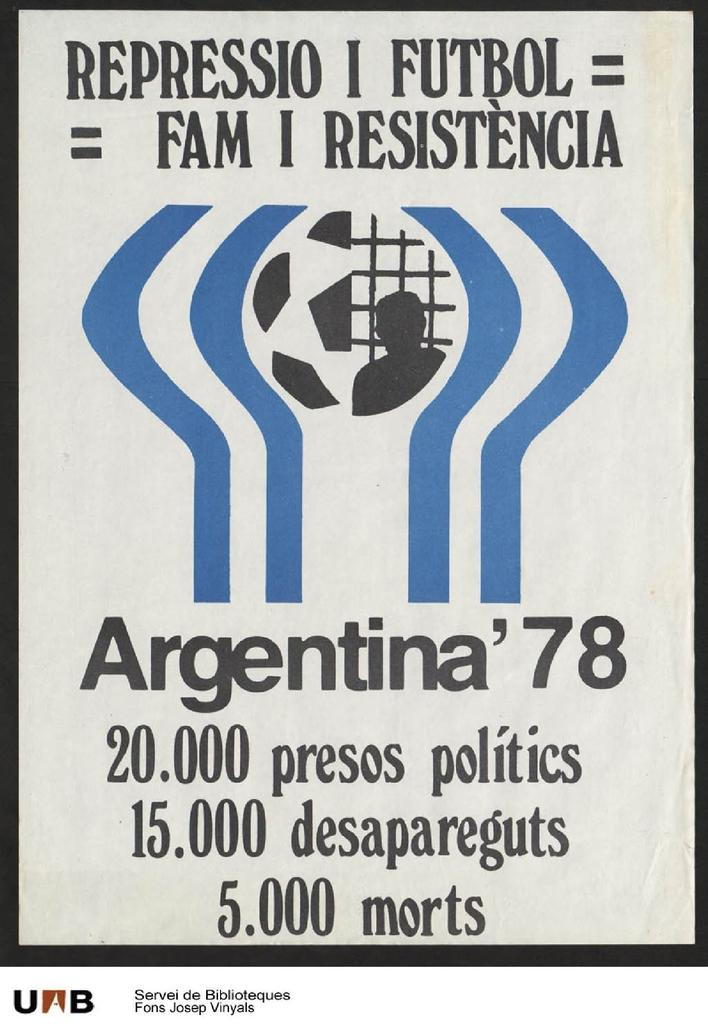Provide a one-sentence caption for the provided image. An advertisement has a soccer ball and Argentina 78 shown on it. 